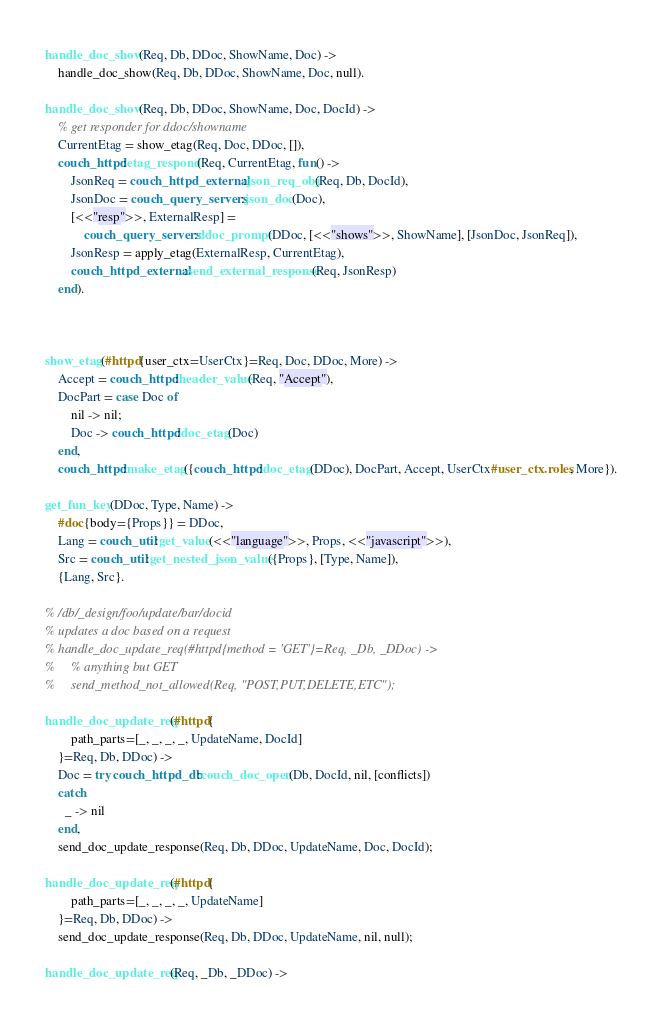<code> <loc_0><loc_0><loc_500><loc_500><_Erlang_>
handle_doc_show(Req, Db, DDoc, ShowName, Doc) ->
    handle_doc_show(Req, Db, DDoc, ShowName, Doc, null).

handle_doc_show(Req, Db, DDoc, ShowName, Doc, DocId) ->
    % get responder for ddoc/showname
    CurrentEtag = show_etag(Req, Doc, DDoc, []),
    couch_httpd:etag_respond(Req, CurrentEtag, fun() ->
        JsonReq = couch_httpd_external:json_req_obj(Req, Db, DocId),
        JsonDoc = couch_query_servers:json_doc(Doc),
        [<<"resp">>, ExternalResp] =
            couch_query_servers:ddoc_prompt(DDoc, [<<"shows">>, ShowName], [JsonDoc, JsonReq]),
        JsonResp = apply_etag(ExternalResp, CurrentEtag),
        couch_httpd_external:send_external_response(Req, JsonResp)
    end).



show_etag(#httpd{user_ctx=UserCtx}=Req, Doc, DDoc, More) ->
    Accept = couch_httpd:header_value(Req, "Accept"),
    DocPart = case Doc of
        nil -> nil;
        Doc -> couch_httpd:doc_etag(Doc)
    end,
    couch_httpd:make_etag({couch_httpd:doc_etag(DDoc), DocPart, Accept, UserCtx#user_ctx.roles, More}).

get_fun_key(DDoc, Type, Name) ->
    #doc{body={Props}} = DDoc,
    Lang = couch_util:get_value(<<"language">>, Props, <<"javascript">>),
    Src = couch_util:get_nested_json_value({Props}, [Type, Name]),
    {Lang, Src}.

% /db/_design/foo/update/bar/docid
% updates a doc based on a request
% handle_doc_update_req(#httpd{method = 'GET'}=Req, _Db, _DDoc) ->
%     % anything but GET
%     send_method_not_allowed(Req, "POST,PUT,DELETE,ETC");
    
handle_doc_update_req(#httpd{
        path_parts=[_, _, _, _, UpdateName, DocId]
    }=Req, Db, DDoc) ->
    Doc = try couch_httpd_db:couch_doc_open(Db, DocId, nil, [conflicts])
    catch
      _ -> nil
    end,
    send_doc_update_response(Req, Db, DDoc, UpdateName, Doc, DocId);

handle_doc_update_req(#httpd{
        path_parts=[_, _, _, _, UpdateName]
    }=Req, Db, DDoc) ->
    send_doc_update_response(Req, Db, DDoc, UpdateName, nil, null);

handle_doc_update_req(Req, _Db, _DDoc) -></code> 